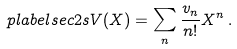<formula> <loc_0><loc_0><loc_500><loc_500>\ p l a b e l { s e c 2 s } V ( X ) = \sum _ { n } \frac { v _ { n } } { n ! } X ^ { n } \, .</formula> 